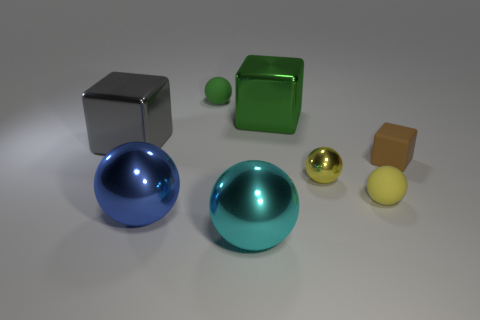Are there any other things that are the same color as the small block?
Give a very brief answer. No. Does the small matte sphere on the left side of the tiny yellow rubber object have the same color as the metal thing that is in front of the large blue object?
Your response must be concise. No. The large cube on the right side of the blue shiny ball is what color?
Provide a succinct answer. Green. Do the rubber object that is on the right side of the yellow matte thing and the large cyan metal thing have the same size?
Your answer should be compact. No. Are there fewer purple rubber blocks than gray objects?
Your response must be concise. Yes. There is a rubber thing that is the same color as the tiny metal sphere; what shape is it?
Provide a succinct answer. Sphere. There is a blue ball; how many tiny brown rubber blocks are in front of it?
Keep it short and to the point. 0. Do the tiny brown matte thing and the tiny shiny thing have the same shape?
Keep it short and to the point. No. What number of objects are to the right of the blue metal ball and behind the big blue shiny sphere?
Make the answer very short. 5. What number of things are either small yellow metallic things or metal objects that are to the right of the blue metallic ball?
Keep it short and to the point. 3. 